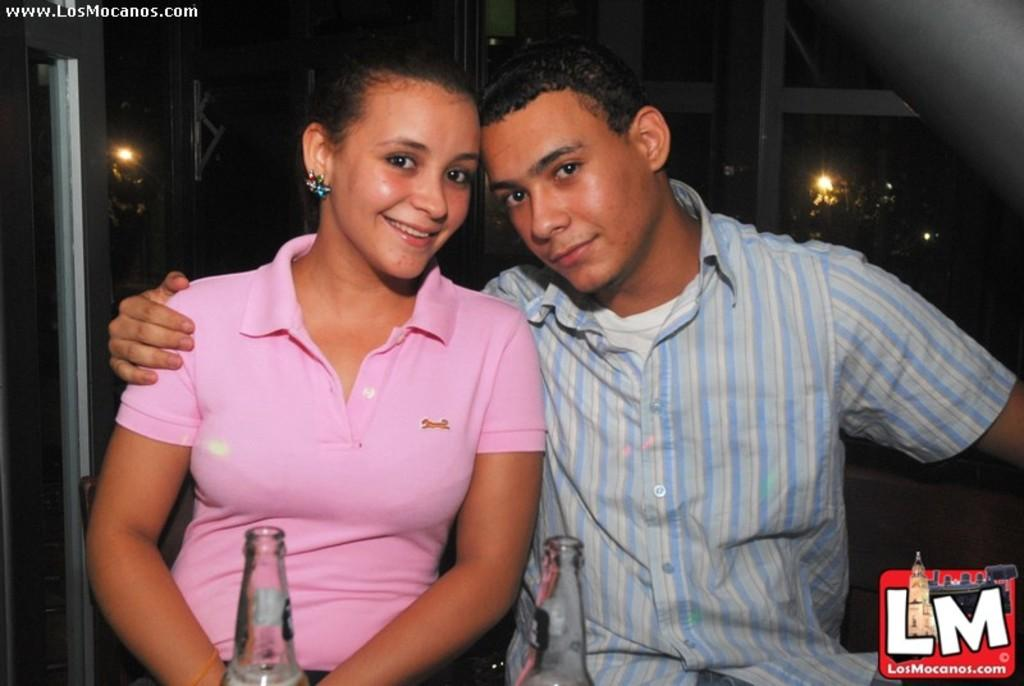How many people are in the image? There are two persons in the image. What are the two persons doing in the image? The two persons are sitting. What objects are in front of the persons? There are two bottles in front of an in front of the persons. What type of comfort do the fairies provide to the persons in the image? There are no fairies present in the image, so it is not possible to determine what comfort they might provide. 